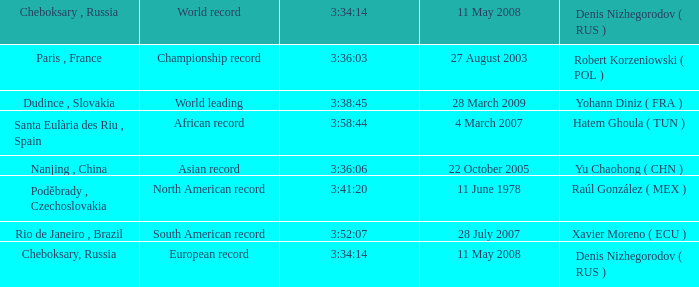When 3:38:45 is  3:34:14 what is the date on May 11th, 2008? 28 March 2009. 